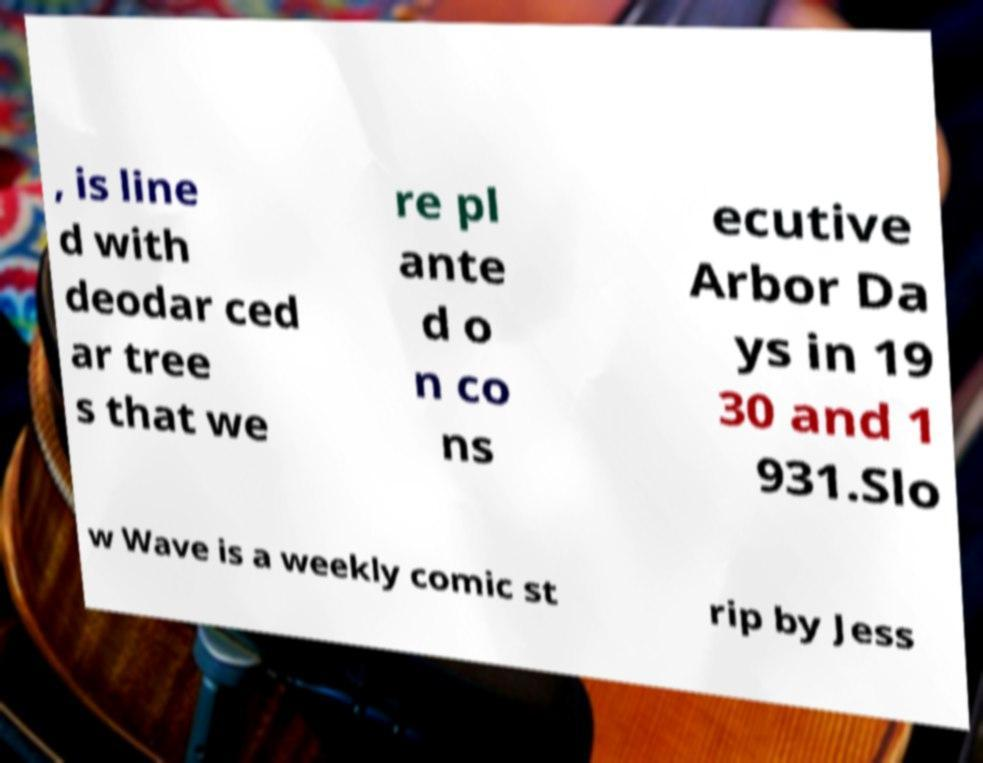What messages or text are displayed in this image? I need them in a readable, typed format. , is line d with deodar ced ar tree s that we re pl ante d o n co ns ecutive Arbor Da ys in 19 30 and 1 931.Slo w Wave is a weekly comic st rip by Jess 